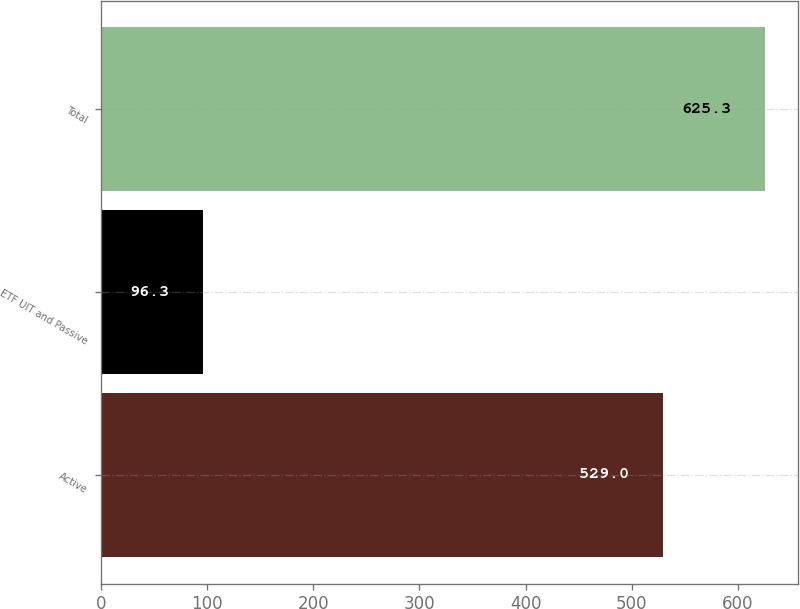<chart> <loc_0><loc_0><loc_500><loc_500><bar_chart><fcel>Active<fcel>ETF UIT and Passive<fcel>Total<nl><fcel>529<fcel>96.3<fcel>625.3<nl></chart> 